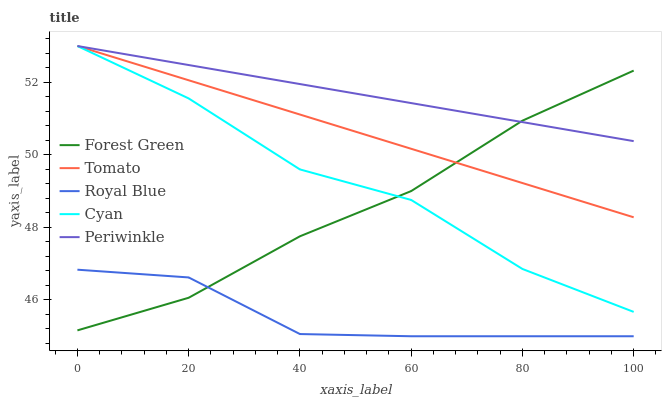Does Royal Blue have the minimum area under the curve?
Answer yes or no. Yes. Does Periwinkle have the maximum area under the curve?
Answer yes or no. Yes. Does Forest Green have the minimum area under the curve?
Answer yes or no. No. Does Forest Green have the maximum area under the curve?
Answer yes or no. No. Is Tomato the smoothest?
Answer yes or no. Yes. Is Cyan the roughest?
Answer yes or no. Yes. Is Royal Blue the smoothest?
Answer yes or no. No. Is Royal Blue the roughest?
Answer yes or no. No. Does Forest Green have the lowest value?
Answer yes or no. No. Does Forest Green have the highest value?
Answer yes or no. No. Is Royal Blue less than Tomato?
Answer yes or no. Yes. Is Cyan greater than Royal Blue?
Answer yes or no. Yes. Does Royal Blue intersect Tomato?
Answer yes or no. No. 